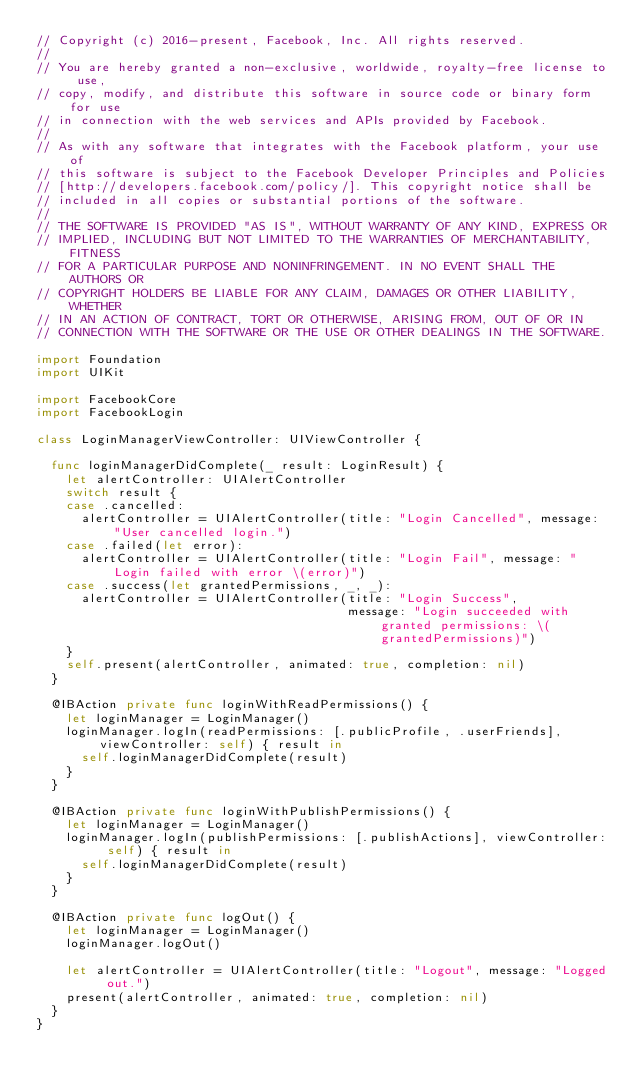Convert code to text. <code><loc_0><loc_0><loc_500><loc_500><_Swift_>// Copyright (c) 2016-present, Facebook, Inc. All rights reserved.
//
// You are hereby granted a non-exclusive, worldwide, royalty-free license to use,
// copy, modify, and distribute this software in source code or binary form for use
// in connection with the web services and APIs provided by Facebook.
//
// As with any software that integrates with the Facebook platform, your use of
// this software is subject to the Facebook Developer Principles and Policies
// [http://developers.facebook.com/policy/]. This copyright notice shall be
// included in all copies or substantial portions of the software.
//
// THE SOFTWARE IS PROVIDED "AS IS", WITHOUT WARRANTY OF ANY KIND, EXPRESS OR
// IMPLIED, INCLUDING BUT NOT LIMITED TO THE WARRANTIES OF MERCHANTABILITY, FITNESS
// FOR A PARTICULAR PURPOSE AND NONINFRINGEMENT. IN NO EVENT SHALL THE AUTHORS OR
// COPYRIGHT HOLDERS BE LIABLE FOR ANY CLAIM, DAMAGES OR OTHER LIABILITY, WHETHER
// IN AN ACTION OF CONTRACT, TORT OR OTHERWISE, ARISING FROM, OUT OF OR IN
// CONNECTION WITH THE SOFTWARE OR THE USE OR OTHER DEALINGS IN THE SOFTWARE.

import Foundation
import UIKit

import FacebookCore
import FacebookLogin

class LoginManagerViewController: UIViewController {

  func loginManagerDidComplete(_ result: LoginResult) {
    let alertController: UIAlertController
    switch result {
    case .cancelled:
      alertController = UIAlertController(title: "Login Cancelled", message: "User cancelled login.")
    case .failed(let error):
      alertController = UIAlertController(title: "Login Fail", message: "Login failed with error \(error)")
    case .success(let grantedPermissions, _, _):
      alertController = UIAlertController(title: "Login Success",
                                          message: "Login succeeded with granted permissions: \(grantedPermissions)")
    }
    self.present(alertController, animated: true, completion: nil)
  }

  @IBAction private func loginWithReadPermissions() {
    let loginManager = LoginManager()
    loginManager.logIn(readPermissions: [.publicProfile, .userFriends], viewController: self) { result in
      self.loginManagerDidComplete(result)
    }
  }

  @IBAction private func loginWithPublishPermissions() {
    let loginManager = LoginManager()
    loginManager.logIn(publishPermissions: [.publishActions], viewController: self) { result in
      self.loginManagerDidComplete(result)
    }
  }

  @IBAction private func logOut() {
    let loginManager = LoginManager()
    loginManager.logOut()

    let alertController = UIAlertController(title: "Logout", message: "Logged out.")
    present(alertController, animated: true, completion: nil)
  }
}
</code> 